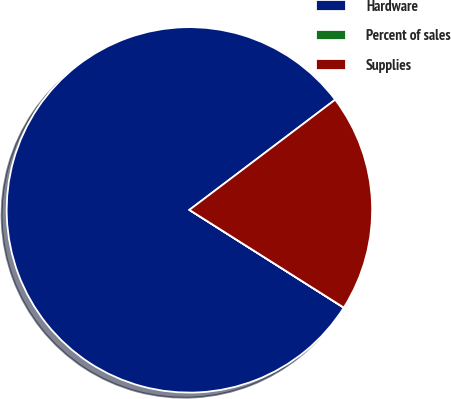Convert chart. <chart><loc_0><loc_0><loc_500><loc_500><pie_chart><fcel>Hardware<fcel>Percent of sales<fcel>Supplies<nl><fcel>80.71%<fcel>0.01%<fcel>19.28%<nl></chart> 